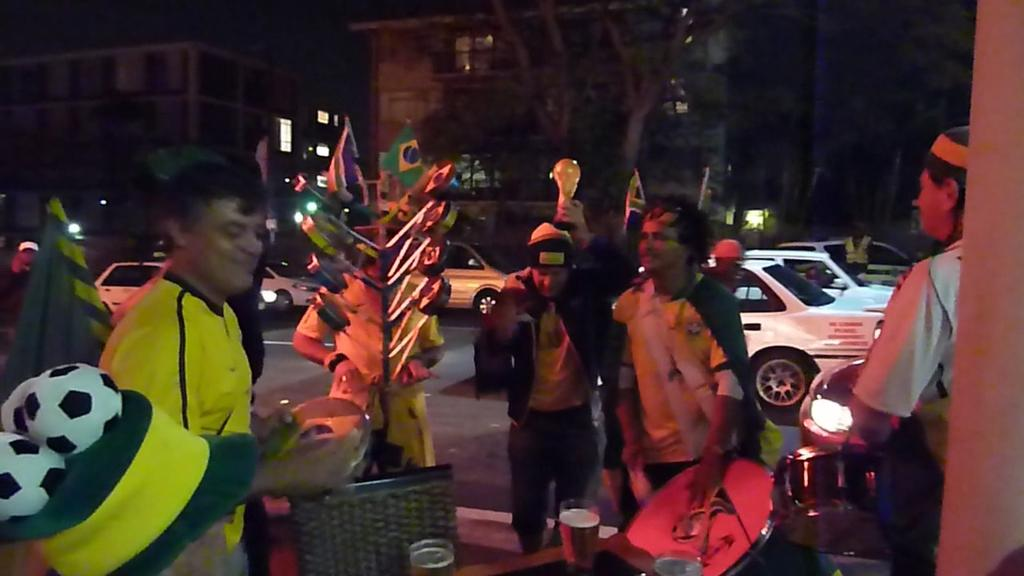How many people are in the image? There is a group of people in the image, but the exact number is not specified. What are the people doing in the image? The people are standing in the image. What are the people wearing? The people are wearing clothes in the image. What can be seen in the middle of the image? There are cars in the middle of the image. What is visible in the background of the image? There are buildings in the background of the image. What song is being sung by the people in the image? There is no indication in the image that the people are singing a song. 